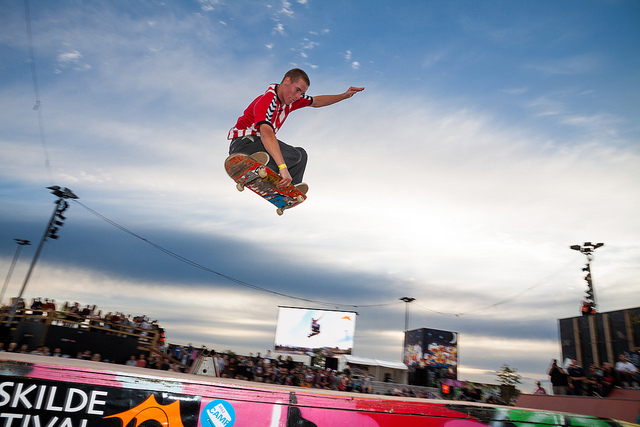What is the name of the trick the man in red is performing?
A. grind
B. manual
C. grab
D. fakie
Answer with the option's letter from the given choices directly. C 